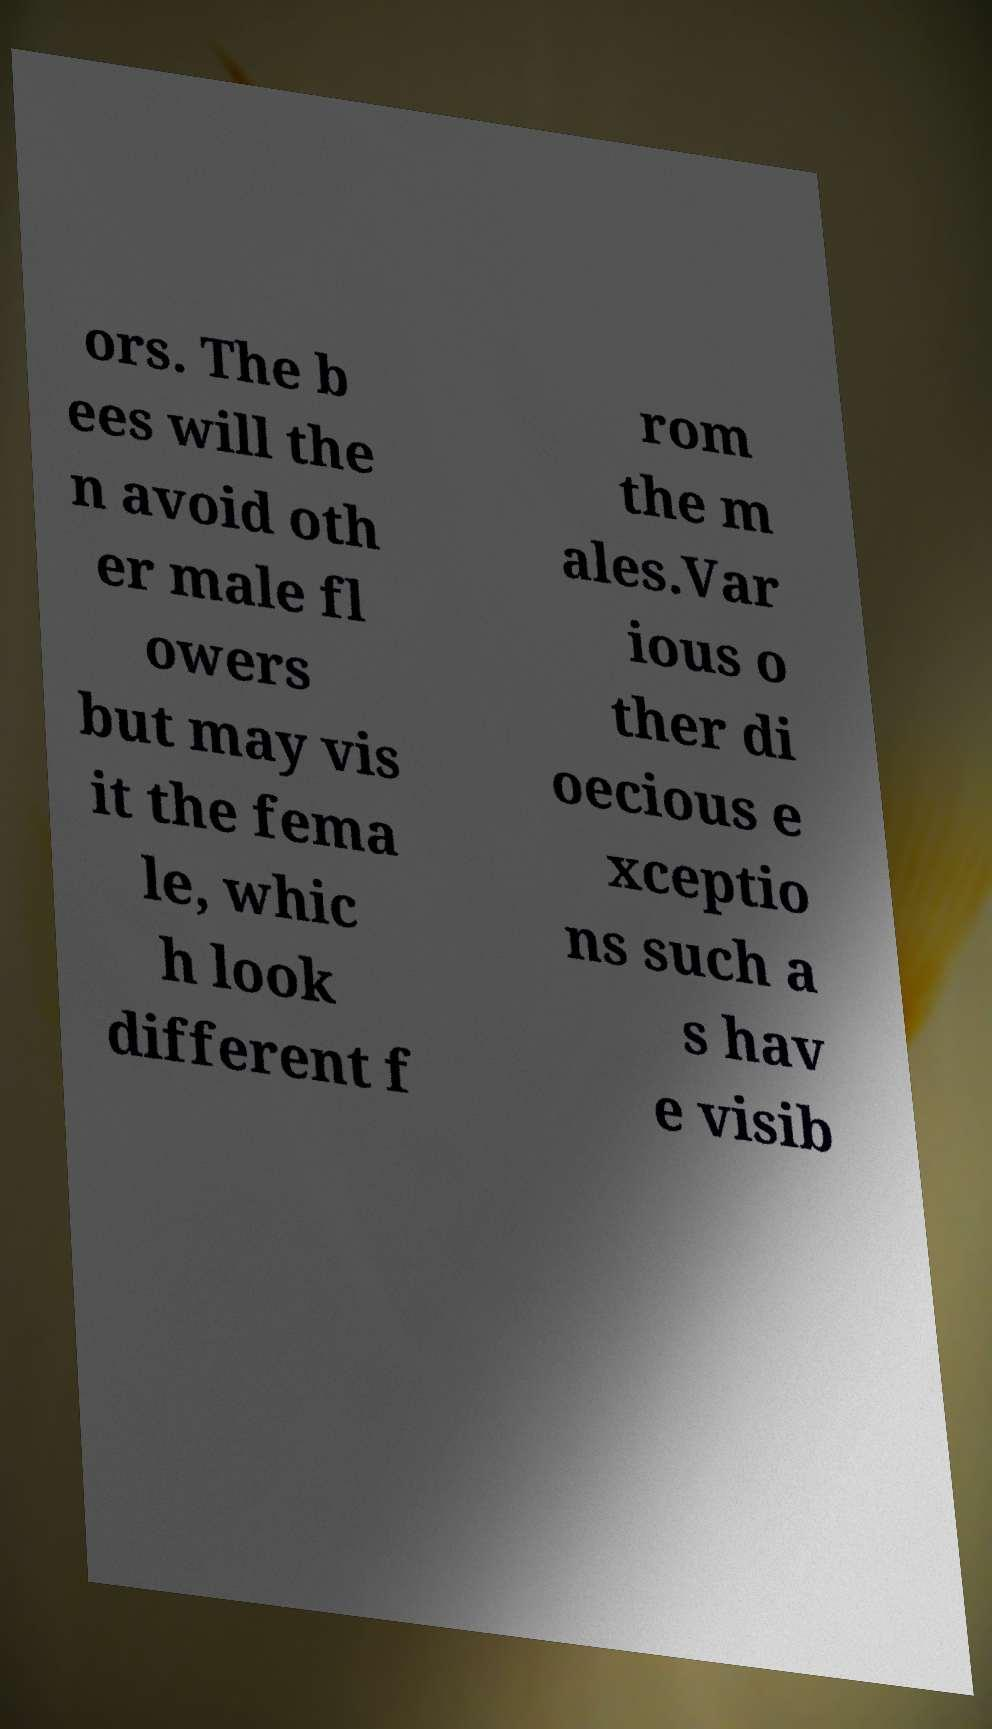I need the written content from this picture converted into text. Can you do that? ors. The b ees will the n avoid oth er male fl owers but may vis it the fema le, whic h look different f rom the m ales.Var ious o ther di oecious e xceptio ns such a s hav e visib 